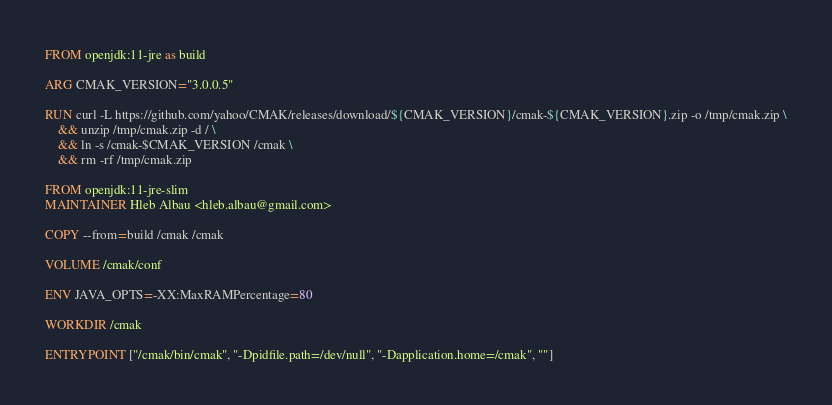<code> <loc_0><loc_0><loc_500><loc_500><_Dockerfile_>FROM openjdk:11-jre as build

ARG CMAK_VERSION="3.0.0.5"

RUN curl -L https://github.com/yahoo/CMAK/releases/download/${CMAK_VERSION}/cmak-${CMAK_VERSION}.zip -o /tmp/cmak.zip \
    && unzip /tmp/cmak.zip -d / \
    && ln -s /cmak-$CMAK_VERSION /cmak \
    && rm -rf /tmp/cmak.zip

FROM openjdk:11-jre-slim
MAINTAINER Hleb Albau <hleb.albau@gmail.com>

COPY --from=build /cmak /cmak

VOLUME /cmak/conf

ENV JAVA_OPTS=-XX:MaxRAMPercentage=80

WORKDIR /cmak

ENTRYPOINT ["/cmak/bin/cmak", "-Dpidfile.path=/dev/null", "-Dapplication.home=/cmak", ""]

</code> 